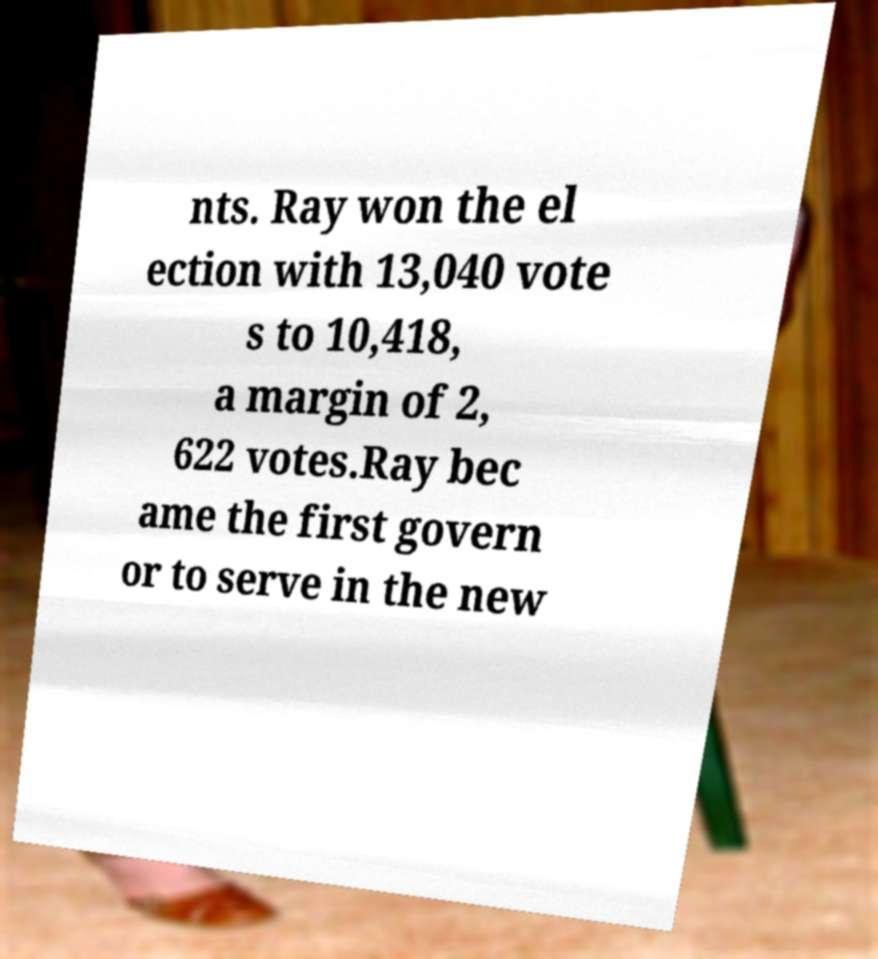Please read and relay the text visible in this image. What does it say? nts. Ray won the el ection with 13,040 vote s to 10,418, a margin of 2, 622 votes.Ray bec ame the first govern or to serve in the new 